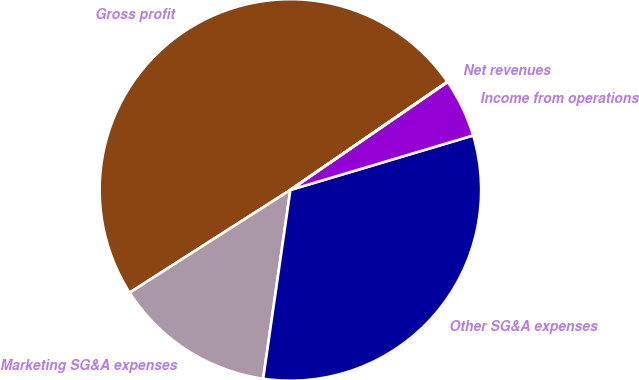Convert chart to OTSL. <chart><loc_0><loc_0><loc_500><loc_500><pie_chart><fcel>Gross profit<fcel>Marketing SG&A expenses<fcel>Other SG&A expenses<fcel>Income from operations<fcel>Net revenues<nl><fcel>49.45%<fcel>13.67%<fcel>31.89%<fcel>4.97%<fcel>0.02%<nl></chart> 